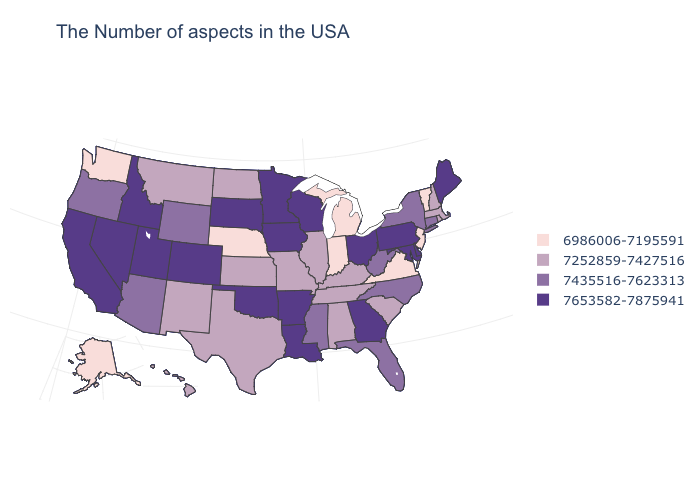Does Nevada have the highest value in the USA?
Give a very brief answer. Yes. Is the legend a continuous bar?
Quick response, please. No. Does the map have missing data?
Give a very brief answer. No. Does Oregon have a higher value than Ohio?
Concise answer only. No. Among the states that border North Carolina , does Virginia have the lowest value?
Answer briefly. Yes. Name the states that have a value in the range 6986006-7195591?
Concise answer only. Vermont, New Jersey, Virginia, Michigan, Indiana, Nebraska, Washington, Alaska. What is the value of Nebraska?
Concise answer only. 6986006-7195591. Does Delaware have the highest value in the South?
Answer briefly. Yes. What is the value of Florida?
Concise answer only. 7435516-7623313. Among the states that border Arkansas , does Mississippi have the lowest value?
Give a very brief answer. No. Does Hawaii have a higher value than North Carolina?
Keep it brief. No. What is the value of Colorado?
Concise answer only. 7653582-7875941. Among the states that border Wisconsin , does Michigan have the lowest value?
Give a very brief answer. Yes. What is the highest value in states that border Washington?
Be succinct. 7653582-7875941. Does Mississippi have the lowest value in the USA?
Answer briefly. No. 